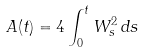<formula> <loc_0><loc_0><loc_500><loc_500>A ( t ) = 4 \int _ { 0 } ^ { t } W _ { s } ^ { 2 } \, d s</formula> 